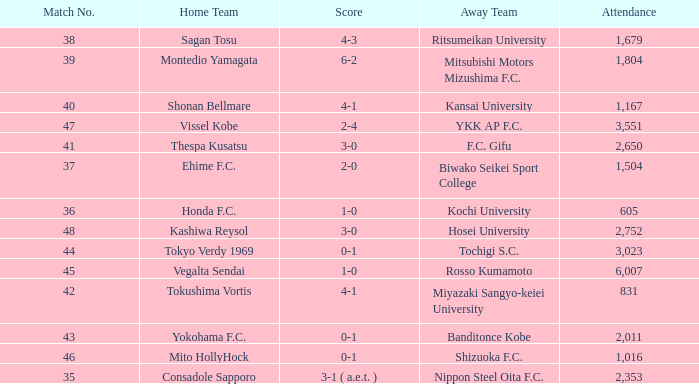Would you be able to parse every entry in this table? {'header': ['Match No.', 'Home Team', 'Score', 'Away Team', 'Attendance'], 'rows': [['38', 'Sagan Tosu', '4-3', 'Ritsumeikan University', '1,679'], ['39', 'Montedio Yamagata', '6-2', 'Mitsubishi Motors Mizushima F.C.', '1,804'], ['40', 'Shonan Bellmare', '4-1', 'Kansai University', '1,167'], ['47', 'Vissel Kobe', '2-4', 'YKK AP F.C.', '3,551'], ['41', 'Thespa Kusatsu', '3-0', 'F.C. Gifu', '2,650'], ['37', 'Ehime F.C.', '2-0', 'Biwako Seikei Sport College', '1,504'], ['36', 'Honda F.C.', '1-0', 'Kochi University', '605'], ['48', 'Kashiwa Reysol', '3-0', 'Hosei University', '2,752'], ['44', 'Tokyo Verdy 1969', '0-1', 'Tochigi S.C.', '3,023'], ['45', 'Vegalta Sendai', '1-0', 'Rosso Kumamoto', '6,007'], ['42', 'Tokushima Vortis', '4-1', 'Miyazaki Sangyo-keiei University', '831'], ['43', 'Yokohama F.C.', '0-1', 'Banditonce Kobe', '2,011'], ['46', 'Mito HollyHock', '0-1', 'Shizuoka F.C.', '1,016'], ['35', 'Consadole Sapporo', '3-1 ( a.e.t. )', 'Nippon Steel Oita F.C.', '2,353']]} After Match 43, what was the Attendance of the Match with a Score of 2-4? 3551.0. 